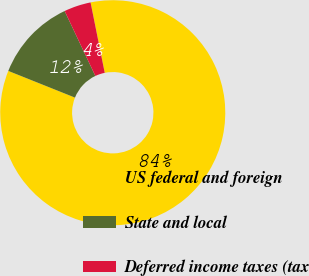<chart> <loc_0><loc_0><loc_500><loc_500><pie_chart><fcel>US federal and foreign<fcel>State and local<fcel>Deferred income taxes (tax<nl><fcel>84.22%<fcel>11.91%<fcel>3.87%<nl></chart> 